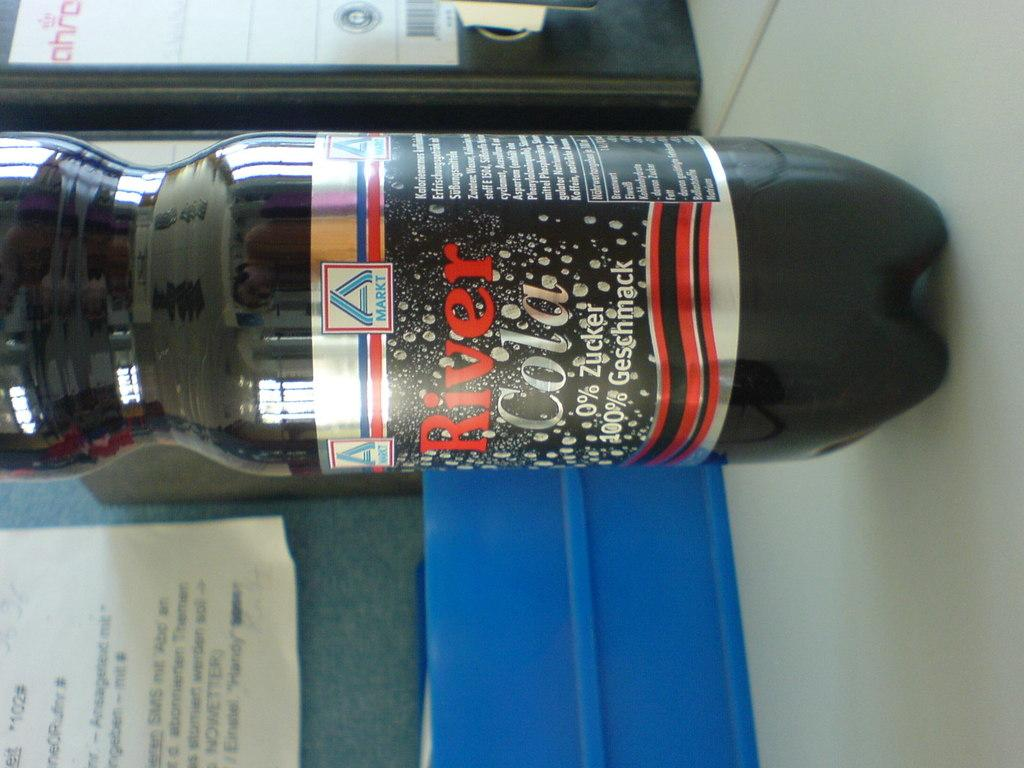<image>
Present a compact description of the photo's key features. A weird shaped bottle of River Cola with 0% zucker 